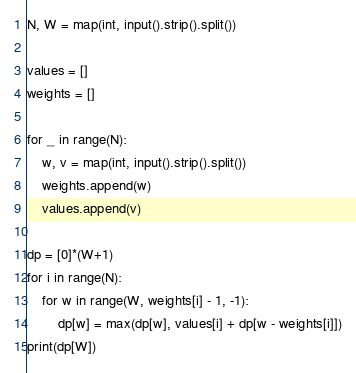<code> <loc_0><loc_0><loc_500><loc_500><_Python_>N, W = map(int, input().strip().split())
 
values = []
weights = []
 
for _ in range(N):
    w, v = map(int, input().strip().split())
    weights.append(w)
    values.append(v)
    
dp = [0]*(W+1)
for i in range(N):
    for w in range(W, weights[i] - 1, -1):
        dp[w] = max(dp[w], values[i] + dp[w - weights[i]])
print(dp[W])</code> 